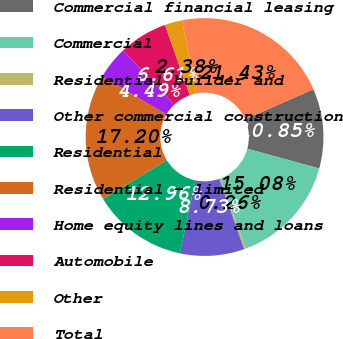Convert chart. <chart><loc_0><loc_0><loc_500><loc_500><pie_chart><fcel>Commercial financial leasing<fcel>Commercial<fcel>Residential builder and<fcel>Other commercial construction<fcel>Residential<fcel>Residential - limited<fcel>Home equity lines and loans<fcel>Automobile<fcel>Other<fcel>Total<nl><fcel>10.85%<fcel>15.08%<fcel>0.26%<fcel>8.73%<fcel>12.96%<fcel>17.2%<fcel>4.49%<fcel>6.61%<fcel>2.38%<fcel>21.43%<nl></chart> 